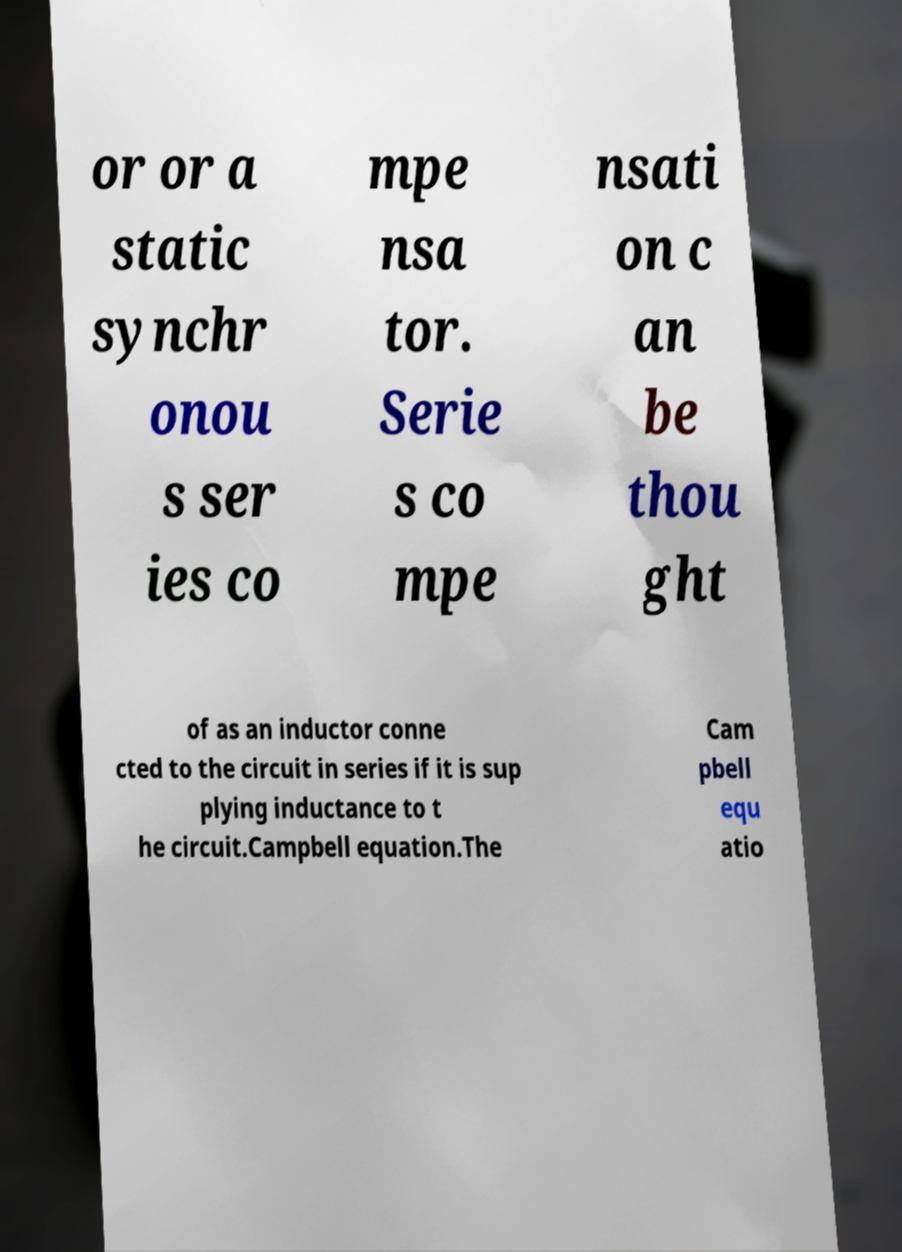I need the written content from this picture converted into text. Can you do that? or or a static synchr onou s ser ies co mpe nsa tor. Serie s co mpe nsati on c an be thou ght of as an inductor conne cted to the circuit in series if it is sup plying inductance to t he circuit.Campbell equation.The Cam pbell equ atio 